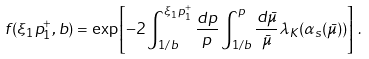Convert formula to latex. <formula><loc_0><loc_0><loc_500><loc_500>f ( \xi _ { 1 } p _ { 1 } ^ { + } , b ) = \exp \left [ - 2 \int _ { 1 / b } ^ { \xi _ { 1 } p _ { 1 } ^ { + } } \frac { d p } { p } \int _ { 1 / b } ^ { p } \frac { d { \bar { \mu } } } { \bar { \mu } } \lambda _ { K } ( \alpha _ { s } ( { \bar { \mu } } ) ) \right ] \, .</formula> 